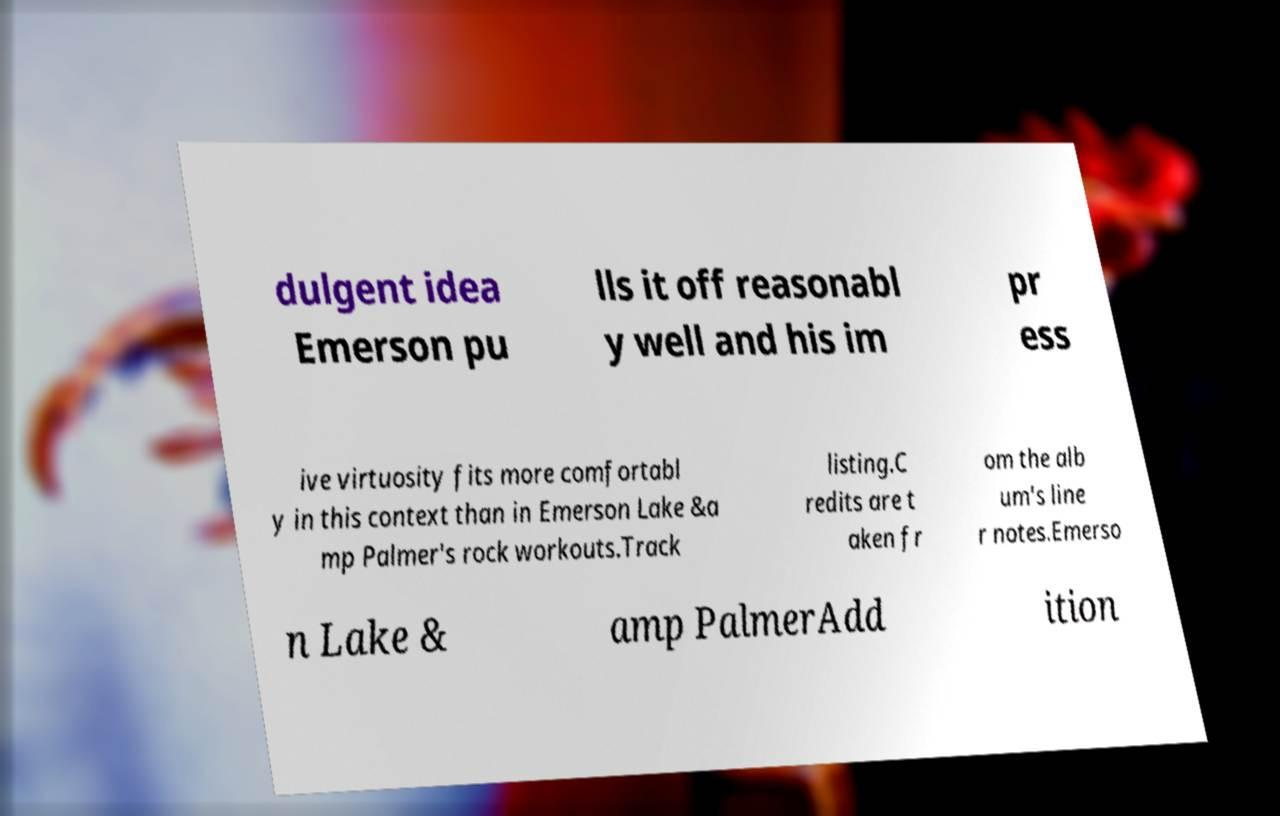I need the written content from this picture converted into text. Can you do that? dulgent idea Emerson pu lls it off reasonabl y well and his im pr ess ive virtuosity fits more comfortabl y in this context than in Emerson Lake &a mp Palmer's rock workouts.Track listing.C redits are t aken fr om the alb um's line r notes.Emerso n Lake & amp PalmerAdd ition 